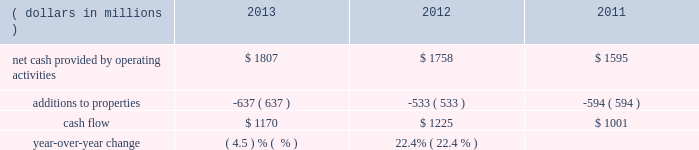General market conditions affecting trust asset performance , future discount rates based on average yields of high quality corporate bonds and our decisions regarding certain elective provisions of the we currently project that we will make total u.s .
And foreign benefit plan contributions in 2014 of approximately $ 57 million .
Actual 2014 contributions could be different from our current projections , as influenced by our decision to undertake discretionary funding of our benefit trusts versus other competing investment priorities , future changes in government requirements , trust asset performance , renewals of union contracts , or higher-than-expected health care claims cost experience .
We measure cash flow as net cash provided by operating activities reduced by expenditures for property additions .
We use this non-gaap financial measure of cash flow to focus management and investors on the amount of cash available for debt repayment , dividend distributions , acquisition opportunities , and share repurchases .
Our cash flow metric is reconciled to the most comparable gaap measure , as follows: .
Year-over-year change ( 4.5 ) % (  % ) 22.4% ( 22.4 % ) the decrease in cash flow ( as defined ) in 2013 compared to 2012 was due primarily to higher capital expenditures .
The increase in cash flow in 2012 compared to 2011 was driven by improved performance in working capital resulting from the one-time benefit derived from the pringles acquisition , as well as changes in the level of capital expenditures during the three-year period .
Investing activities our net cash used in investing activities for 2013 amounted to $ 641 million , a decrease of $ 2604 million compared with 2012 primarily attributable to the $ 2668 million acquisition of pringles in 2012 .
Capital spending in 2013 included investments in our supply chain infrastructure , and to support capacity requirements in certain markets , including pringles .
In addition , we continued the investment in our information technology infrastructure related to the reimplementation and upgrade of our sap platform .
Net cash used in investing activities of $ 3245 million in 2012 increased by $ 2658 million compared with 2011 , due to the acquisition of pringles in 2012 .
Cash paid for additions to properties as a percentage of net sales has increased to 4.3% ( 4.3 % ) in 2013 , from 3.8% ( 3.8 % ) in 2012 , which was a decrease from 4.5% ( 4.5 % ) in financing activities our net cash used by financing activities was $ 1141 million for 2013 , compared to net cash provided by financing activities of $ 1317 million for 2012 and net cash used in financing activities of $ 957 million for 2011 .
The increase in cash provided from financing activities in 2012 compared to 2013 and 2011 , was primarily due to the issuance of debt related to the acquisition of pringles .
Total debt was $ 7.4 billion at year-end 2013 and $ 7.9 billion at year-end 2012 .
In february 2013 , we issued $ 250 million of two-year floating-rate u.s .
Dollar notes , and $ 400 million of ten-year 2.75% ( 2.75 % ) u.s .
Dollar notes , resulting in aggregate net proceeds after debt discount of $ 645 million .
The proceeds from these notes were used for general corporate purposes , including , together with cash on hand , repayment of the $ 750 million aggregate principal amount of our 4.25% ( 4.25 % ) u.s .
Dollar notes due march 2013 .
In may 2012 , we issued $ 350 million of three-year 1.125% ( 1.125 % ) u.s .
Dollar notes , $ 400 million of five-year 1.75% ( 1.75 % ) u.s .
Dollar notes and $ 700 million of ten-year 3.125% ( 3.125 % ) u.s .
Dollar notes , resulting in aggregate net proceeds after debt discount of $ 1.442 billion .
The proceeds of these notes were used for general corporate purposes , including financing a portion of the acquisition of pringles .
In may 2012 , we issued cdn .
$ 300 million of two-year 2.10% ( 2.10 % ) fixed rate canadian dollar notes , using the proceeds from these notes for general corporate purposes , which included repayment of intercompany debt .
This repayment resulted in cash available to be used for a portion of the acquisition of pringles .
In december 2012 , we repaid $ 750 million five-year 5.125% ( 5.125 % ) u.s .
Dollar notes at maturity with commercial paper .
In april 2011 , we repaid $ 945 million ten-year 6.60% ( 6.60 % ) u.s .
Dollar notes at maturity with commercial paper .
In may 2011 , we issued $ 400 million of seven-year 3.25% ( 3.25 % ) fixed rate u.s .
Dollar notes , using the proceeds of $ 397 million for general corporate purposes and repayment of commercial paper .
In november 2011 , we issued $ 500 million of five-year 1.875% ( 1.875 % ) fixed rate u .
Dollar notes , using the proceeds of $ 498 million for general corporate purposes and repayment of commercial paper. .
What was the net cash used by investing activities in 2011 in millions? 
Computations: (3245 - 2658)
Answer: 587.0. 